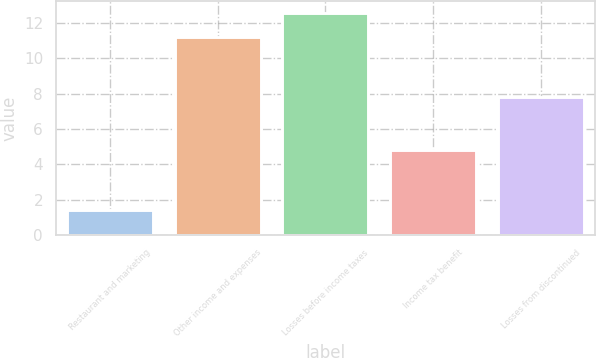<chart> <loc_0><loc_0><loc_500><loc_500><bar_chart><fcel>Restaurant and marketing<fcel>Other income and expenses<fcel>Losses before income taxes<fcel>Income tax benefit<fcel>Losses from discontinued<nl><fcel>1.4<fcel>11.2<fcel>12.6<fcel>4.8<fcel>7.8<nl></chart> 